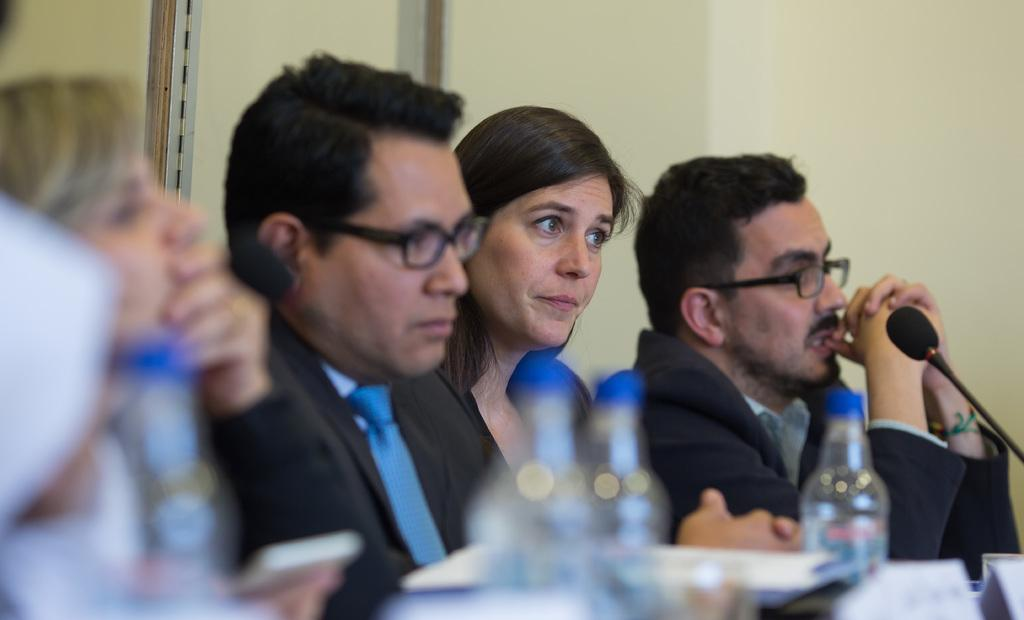What are the people in the image doing? The people in the image are sitting. What items can be seen for hydration in the image? There are water bottles in the image. What object is used for amplifying sound in the image? There is a microphone in the image. Can you describe any other objects present in the image? There are other unspecified objects in the image. What type of rice is being served in the image? There is no rice present in the image. What is the tendency of the base in the image? There is no base present in the image, so it's not possible to determine its tendency. 